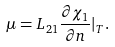Convert formula to latex. <formula><loc_0><loc_0><loc_500><loc_500>\mu = L _ { 2 1 } \frac { \partial \chi _ { 1 } } { \partial n } | _ { T } .</formula> 